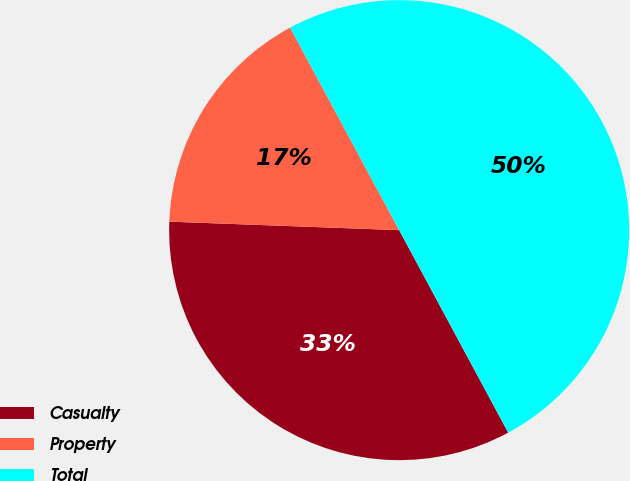Convert chart. <chart><loc_0><loc_0><loc_500><loc_500><pie_chart><fcel>Casualty<fcel>Property<fcel>Total<nl><fcel>33.45%<fcel>16.55%<fcel>50.0%<nl></chart> 